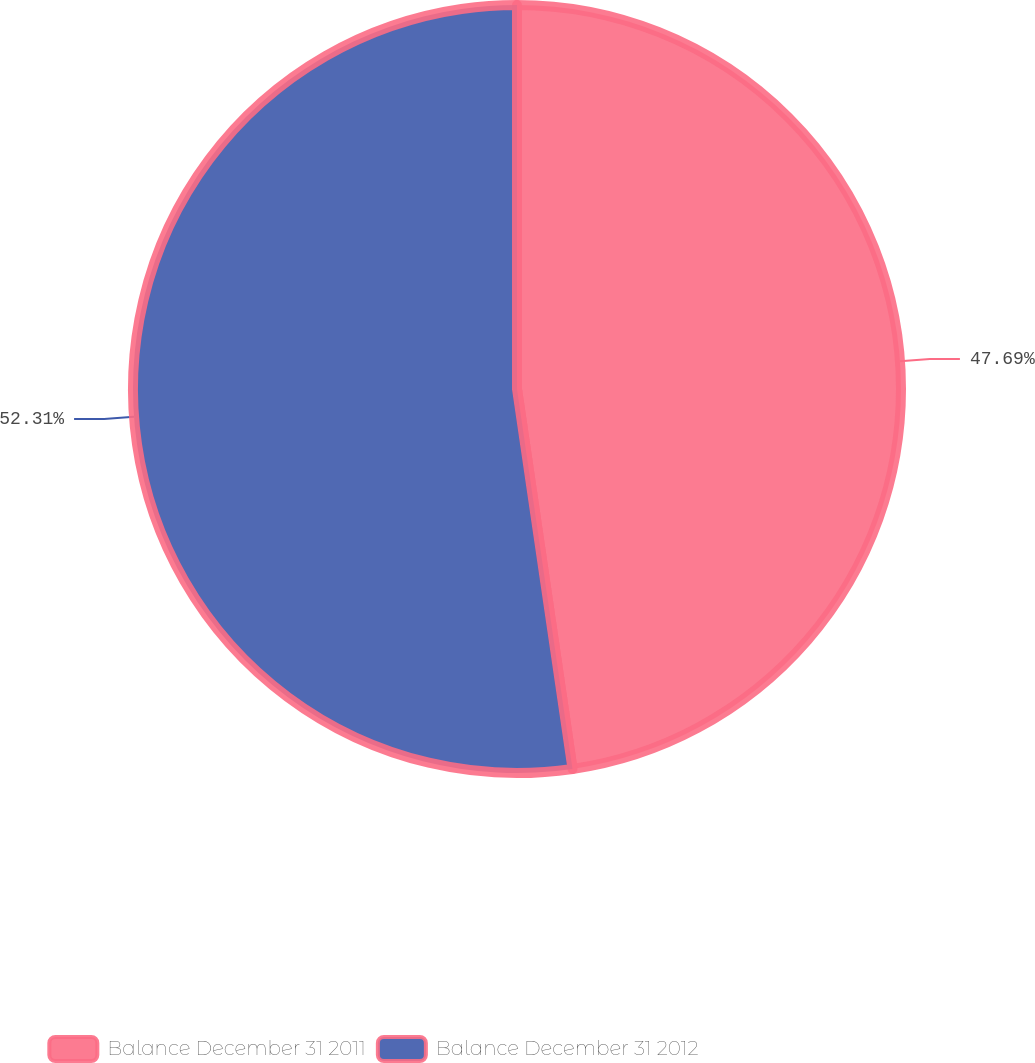<chart> <loc_0><loc_0><loc_500><loc_500><pie_chart><fcel>Balance December 31 2011<fcel>Balance December 31 2012<nl><fcel>47.69%<fcel>52.31%<nl></chart> 